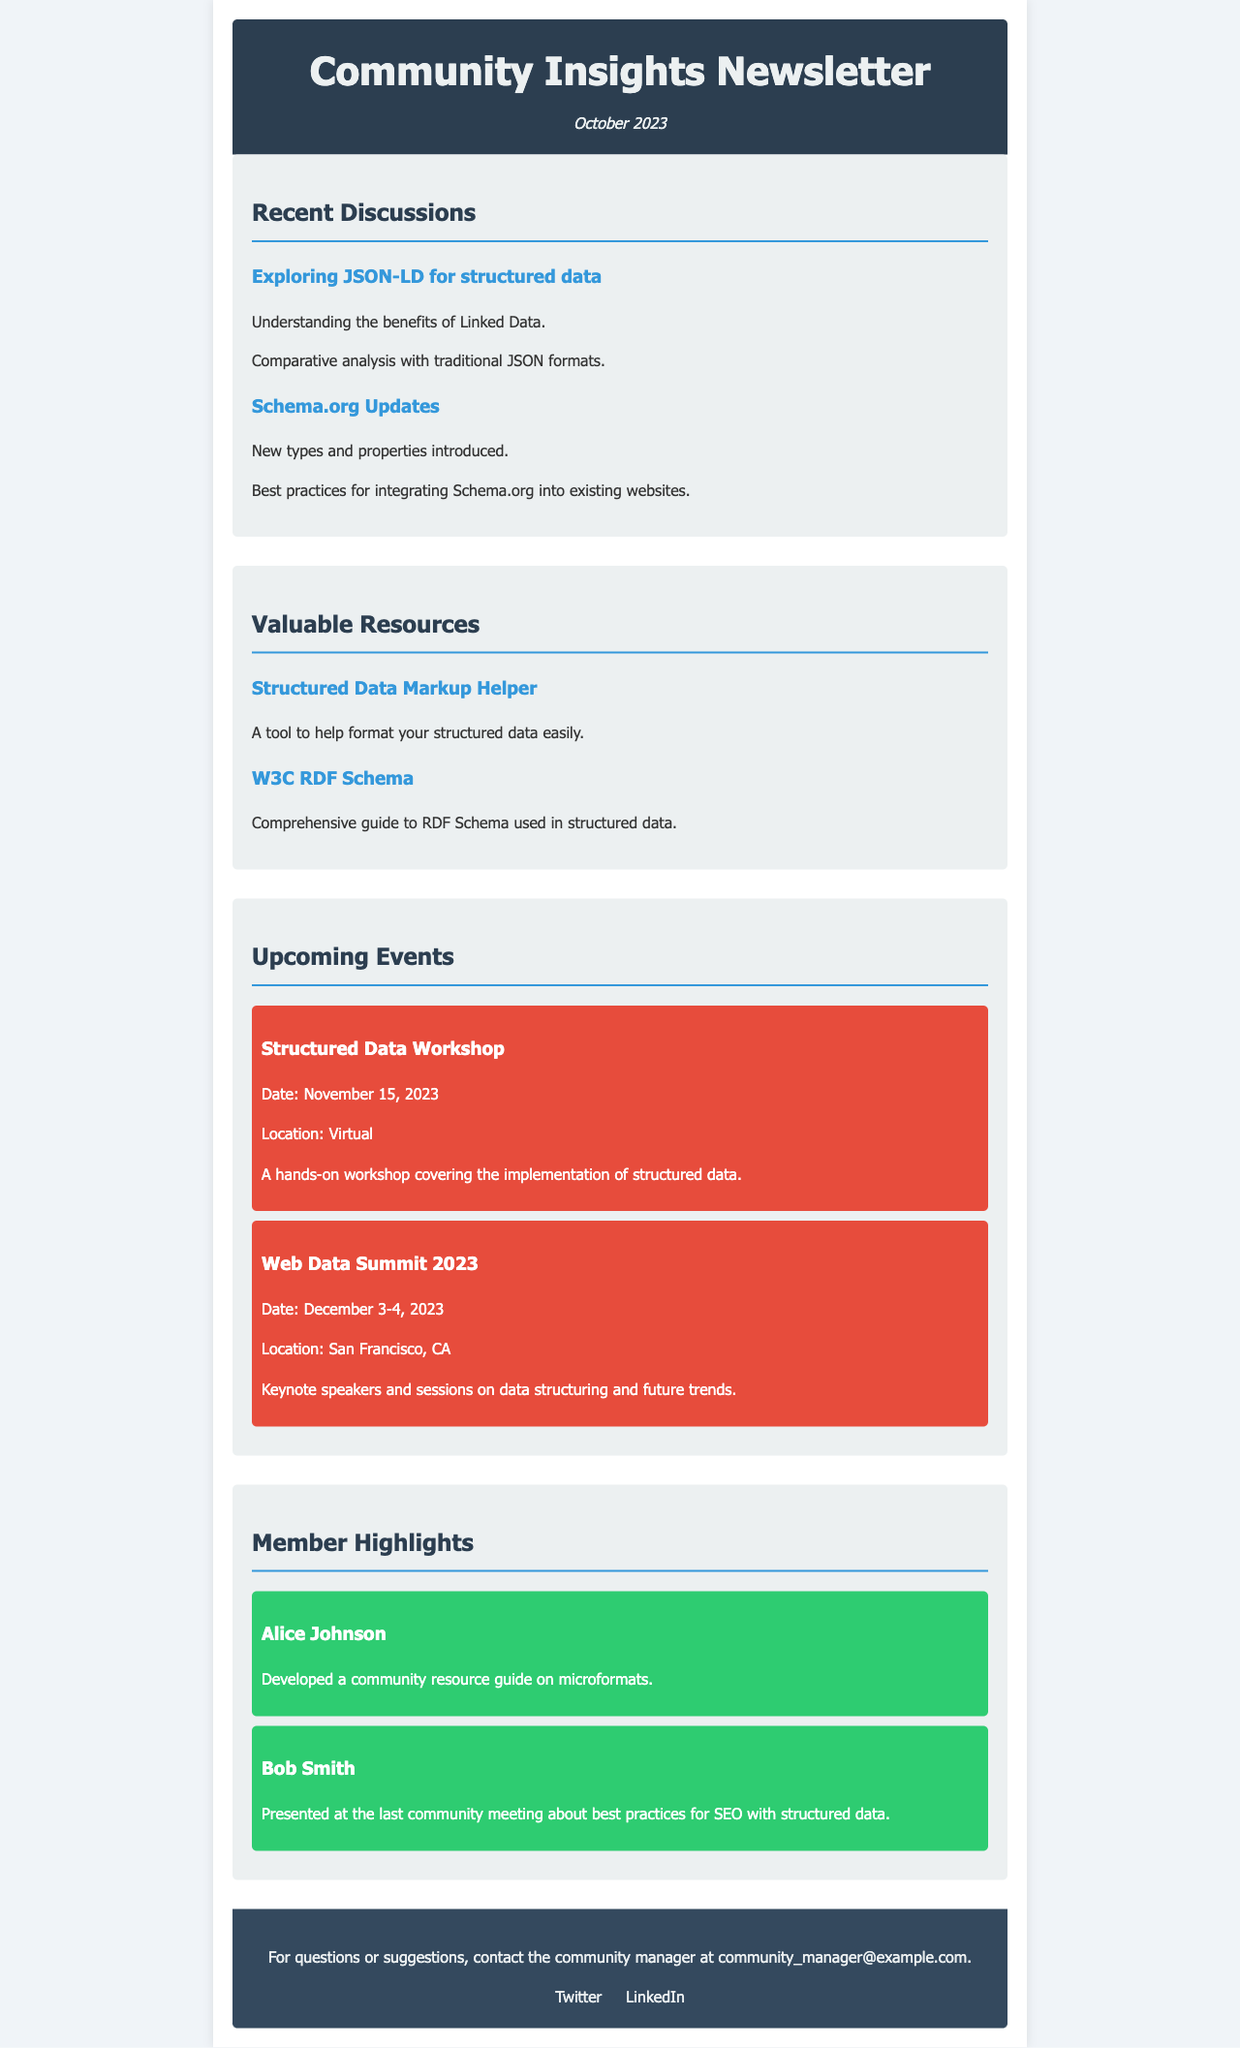what is the title of the newsletter? The title of the newsletter is mentioned in the header section of the document.
Answer: Community Insights Newsletter what is the publication date of the newsletter? The publication date is found just below the title in the header section.
Answer: October 2023 what is the first discussion topic listed? The first discussion topic is the first bullet point under the Recent Discussions section.
Answer: Exploring JSON-LD for structured data how many resources are listed in the Valuable Resources section? The number of resources can be counted from the list in that section.
Answer: 2 when is the Structured Data Workshop scheduled? The date of the workshop is mentioned in the Upcoming Events section.
Answer: November 15, 2023 who developed a community resource guide? This information is found in the Member Highlights section and refers to one member.
Answer: Alice Johnson what color is the event section background? The color of the event section is described in the CSS properties relevant to that section.
Answer: e74c3c what is the location of the Web Data Summit 2023? The location of the summit is specified in the Upcoming Events section.
Answer: San Francisco, CA how can you contact the community manager? The contact method is provided in the footer of the document.
Answer: community_manager@example.com 